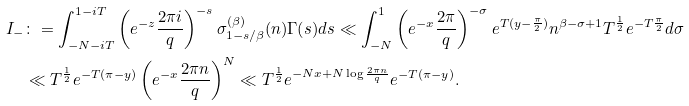Convert formula to latex. <formula><loc_0><loc_0><loc_500><loc_500>I _ { - } & \colon = \int _ { - N - i T } ^ { 1 - i T } \left ( e ^ { - z } \frac { 2 \pi i } { q } \right ) ^ { - s } \sigma _ { 1 - s / \beta } ^ { ( \beta ) } ( n ) \Gamma ( s ) d s \ll \int _ { - N } ^ { 1 } \left ( e ^ { - x } \frac { 2 \pi } { q } \right ) ^ { - \sigma } e ^ { T ( y - \frac { \pi } { 2 } ) } n ^ { \beta - \sigma + 1 } T ^ { \frac { 1 } { 2 } } e ^ { - T \frac { \pi } { 2 } } d \sigma \\ & \ll T ^ { \frac { 1 } { 2 } } e ^ { - T ( \pi - y ) } \left ( e ^ { - x } \frac { 2 \pi n } { q } \right ) ^ { N } \ll T ^ { \frac { 1 } { 2 } } e ^ { - N x + N \log \frac { 2 \pi n } { q } } e ^ { - T ( \pi - y ) } .</formula> 